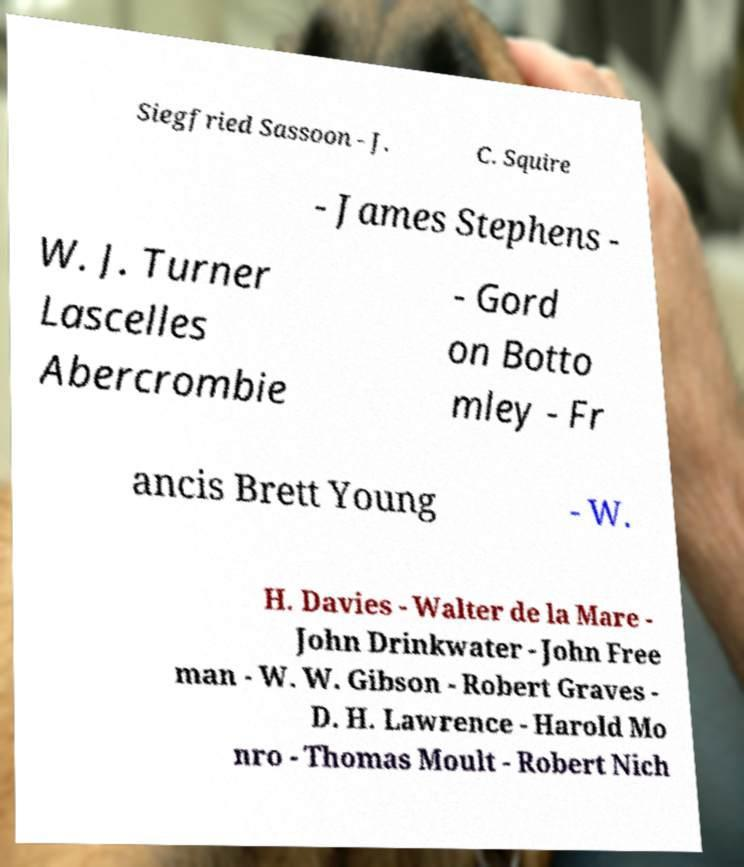Could you assist in decoding the text presented in this image and type it out clearly? Siegfried Sassoon - J. C. Squire - James Stephens - W. J. Turner Lascelles Abercrombie - Gord on Botto mley - Fr ancis Brett Young - W. H. Davies - Walter de la Mare - John Drinkwater - John Free man - W. W. Gibson - Robert Graves - D. H. Lawrence - Harold Mo nro - Thomas Moult - Robert Nich 